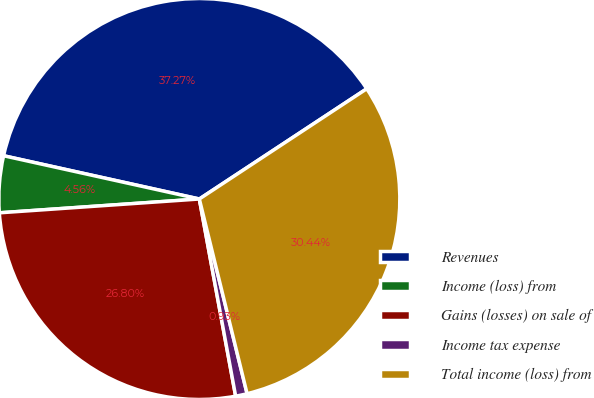<chart> <loc_0><loc_0><loc_500><loc_500><pie_chart><fcel>Revenues<fcel>Income (loss) from<fcel>Gains (losses) on sale of<fcel>Income tax expense<fcel>Total income (loss) from<nl><fcel>37.27%<fcel>4.56%<fcel>26.8%<fcel>0.93%<fcel>30.44%<nl></chart> 